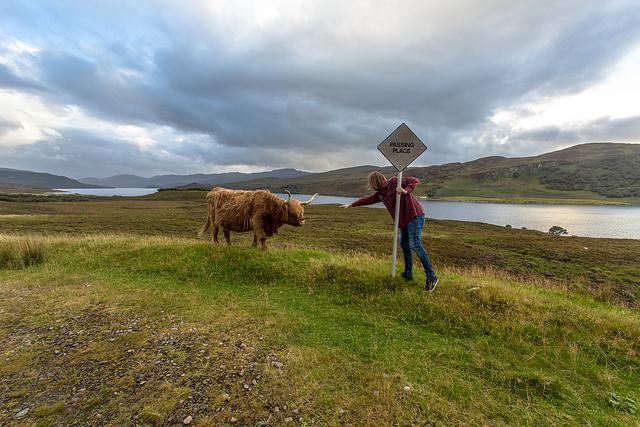What is this cow doing?
Be succinct. Walking. Is the man afraid of the cow?
Concise answer only. No. What kind of landscape is this?
Write a very short answer. Rural. Is there water in the background?
Keep it brief. Yes. 